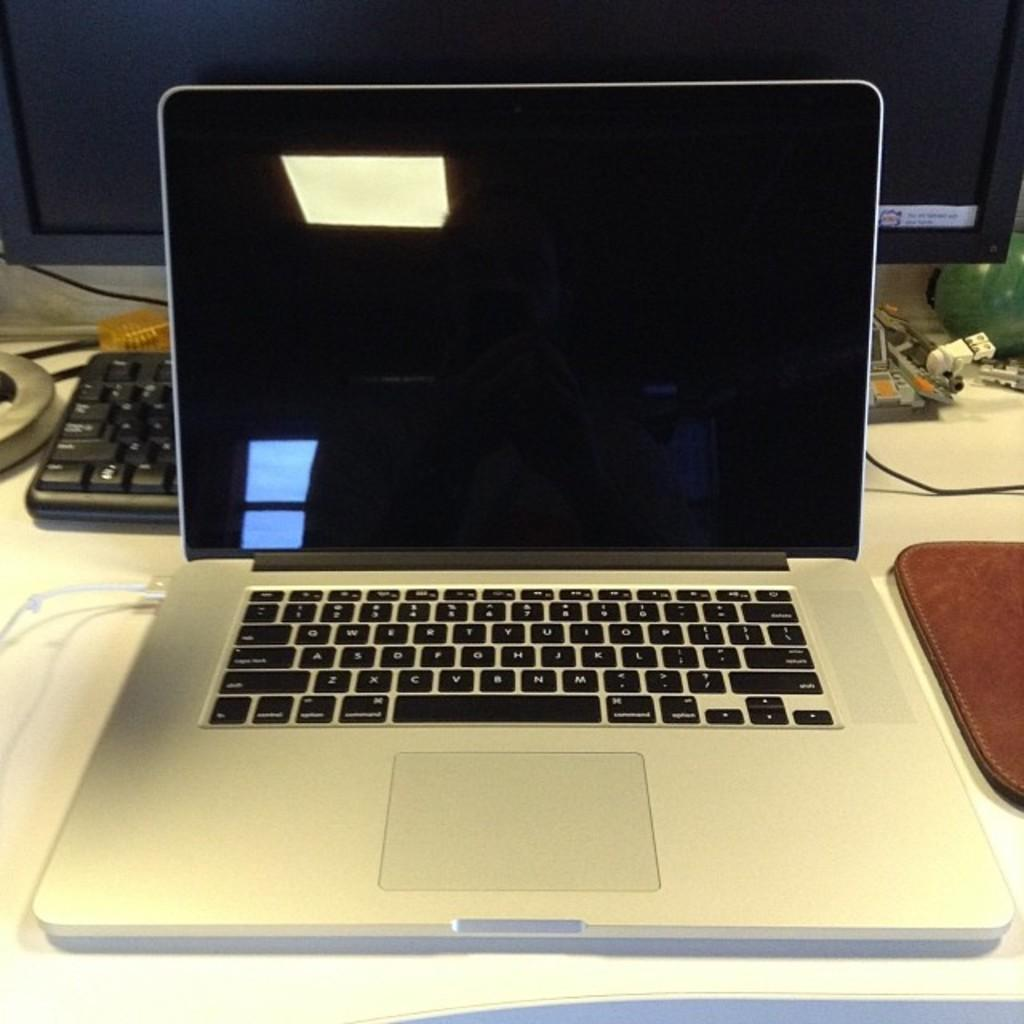Provide a one-sentence caption for the provided image. a keyboard with the letter z on the left side. 